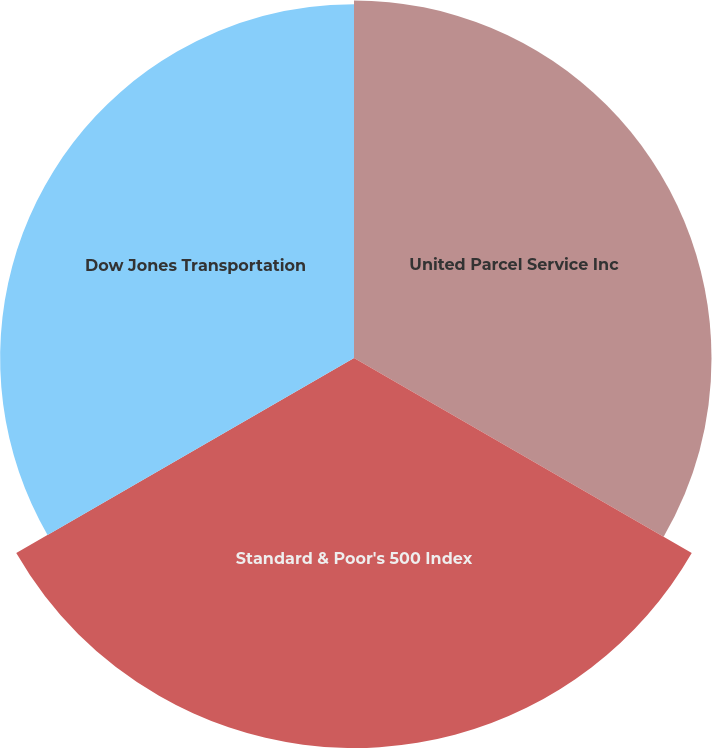<chart> <loc_0><loc_0><loc_500><loc_500><pie_chart><fcel>United Parcel Service Inc<fcel>Standard & Poor's 500 Index<fcel>Dow Jones Transportation<nl><fcel>32.46%<fcel>35.41%<fcel>32.13%<nl></chart> 